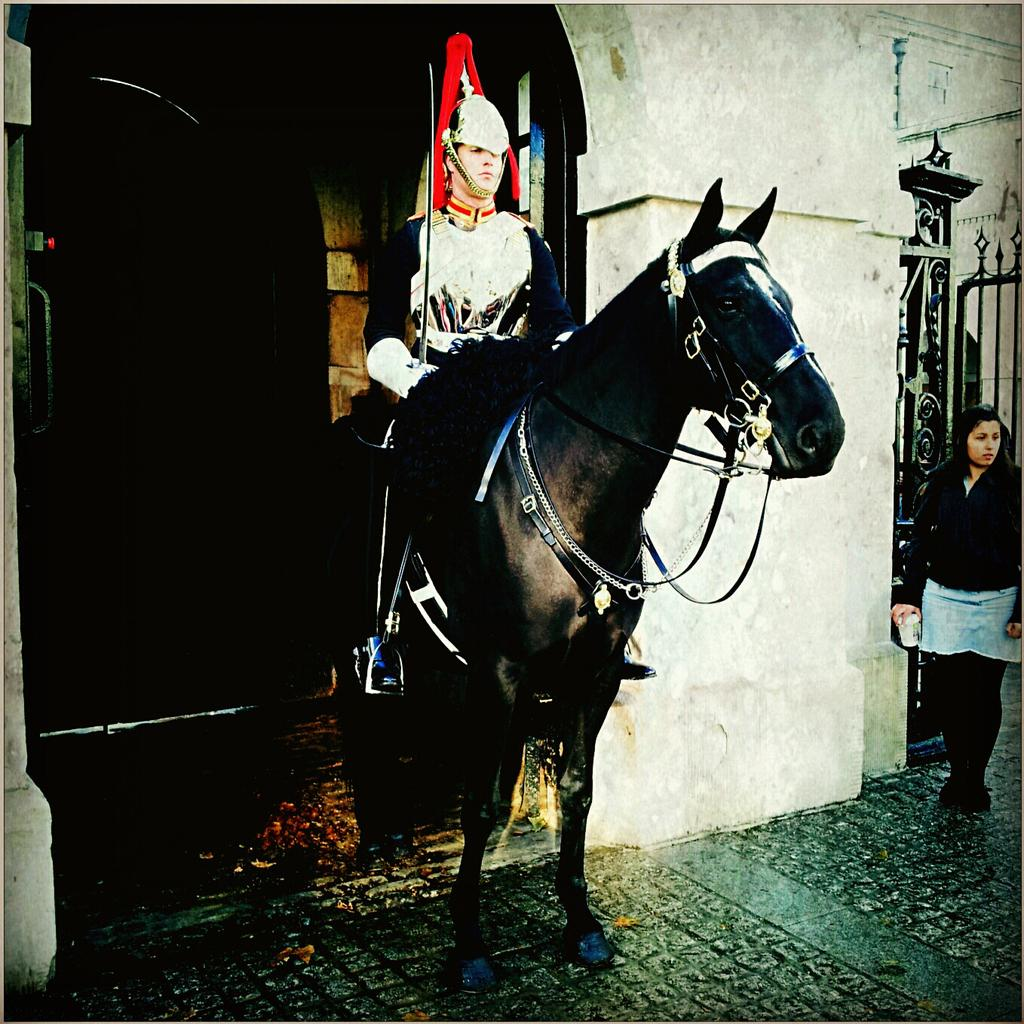What is the man in the image holding? The man is holding a sword in the image. What is the man doing while holding the sword? The man is sitting on a horse. Who else is present in the image? There is a woman standing at the right side of the image. What can be seen in the background of the image? There appears to be a door in the background of the image. What type of gun is the man using to shoot at the enemy in the image? There is no gun present in the image; the man is holding a sword. What kind of street can be seen in the background of the image? There is no street visible in the image; only a door can be seen in the background. 